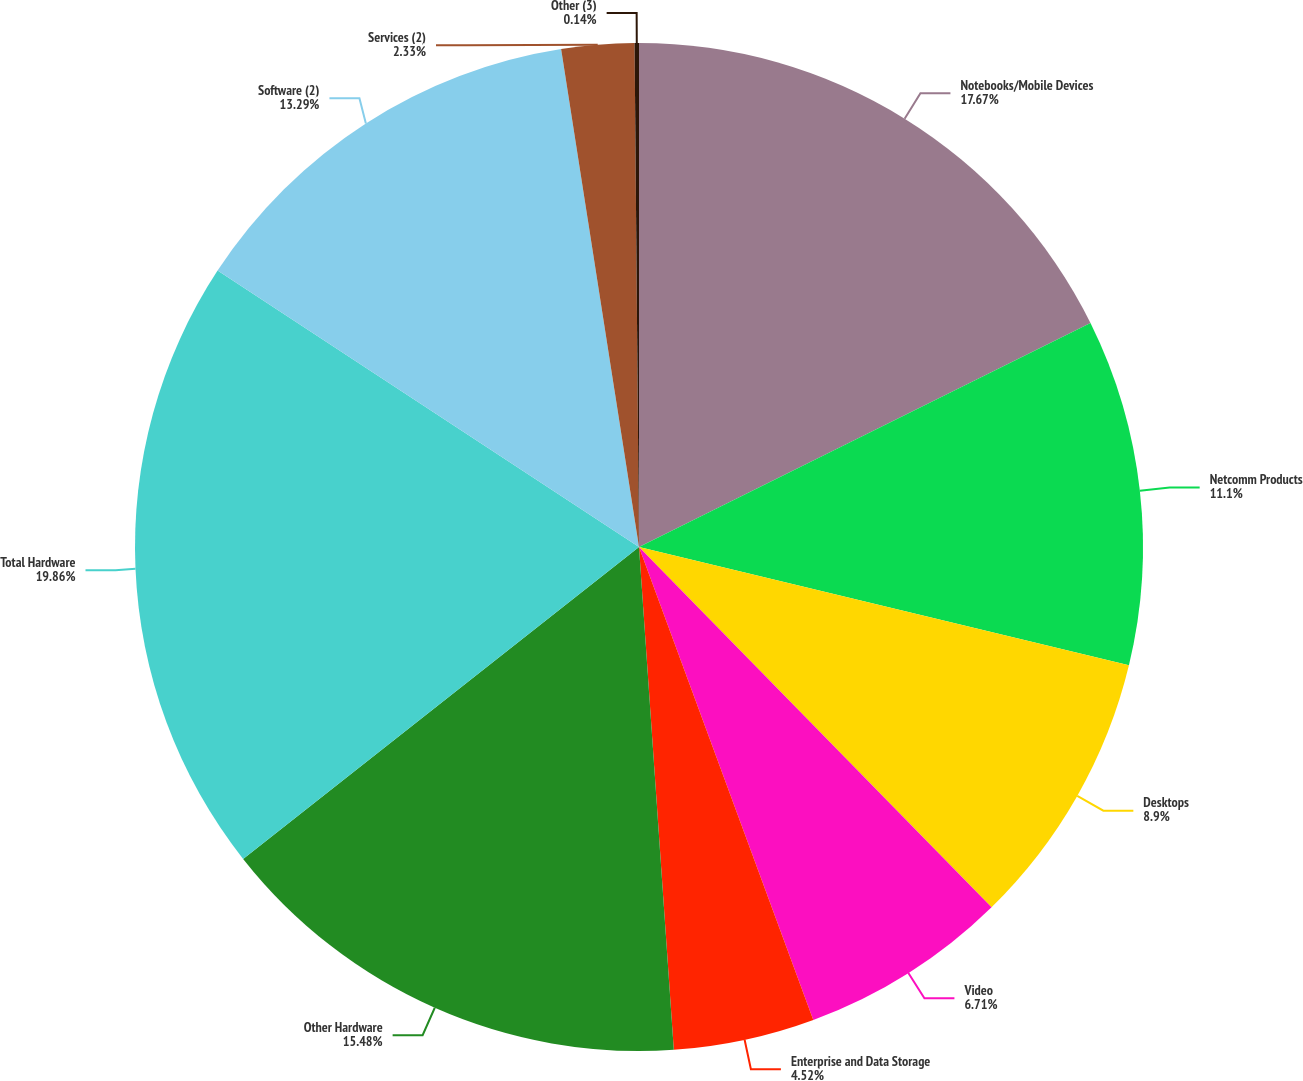Convert chart. <chart><loc_0><loc_0><loc_500><loc_500><pie_chart><fcel>Notebooks/Mobile Devices<fcel>Netcomm Products<fcel>Desktops<fcel>Video<fcel>Enterprise and Data Storage<fcel>Other Hardware<fcel>Total Hardware<fcel>Software (2)<fcel>Services (2)<fcel>Other (3)<nl><fcel>17.67%<fcel>11.1%<fcel>8.9%<fcel>6.71%<fcel>4.52%<fcel>15.48%<fcel>19.86%<fcel>13.29%<fcel>2.33%<fcel>0.14%<nl></chart> 